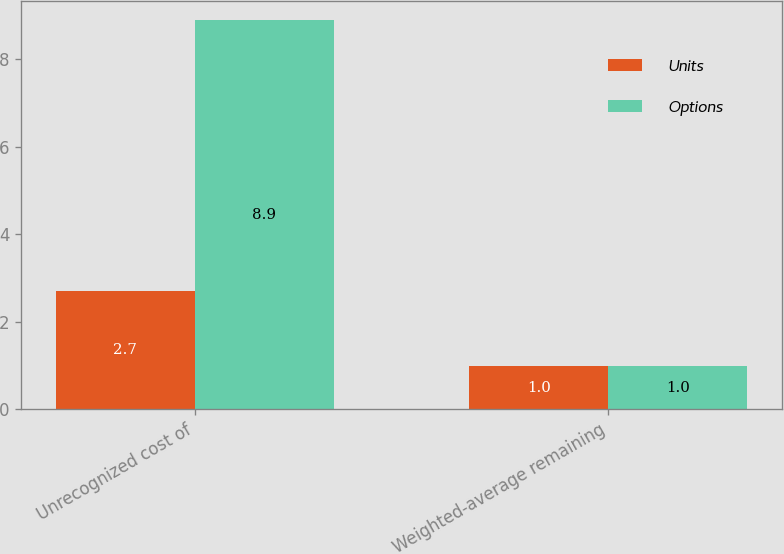Convert chart to OTSL. <chart><loc_0><loc_0><loc_500><loc_500><stacked_bar_chart><ecel><fcel>Unrecognized cost of<fcel>Weighted-average remaining<nl><fcel>Units<fcel>2.7<fcel>1<nl><fcel>Options<fcel>8.9<fcel>1<nl></chart> 